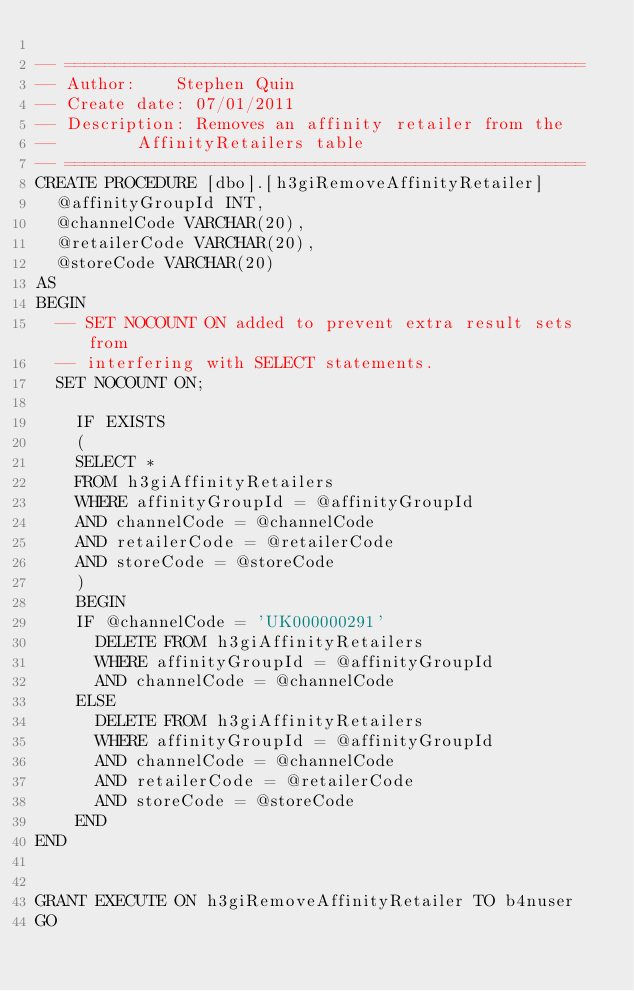Convert code to text. <code><loc_0><loc_0><loc_500><loc_500><_SQL_>
-- ====================================================
-- Author:		Stephen Quin
-- Create date: 07/01/2011
-- Description:	Removes an affinity retailer from the
--				AffinityRetailers table
-- ====================================================
CREATE PROCEDURE [dbo].[h3giRemoveAffinityRetailer] 
	@affinityGroupId INT,
	@channelCode VARCHAR(20),
	@retailerCode VARCHAR(20),
	@storeCode VARCHAR(20)
AS
BEGIN
	-- SET NOCOUNT ON added to prevent extra result sets from
	-- interfering with SELECT statements.
	SET NOCOUNT ON;

    IF EXISTS 
    (
		SELECT * 
		FROM h3giAffinityRetailers
		WHERE affinityGroupId = @affinityGroupId
		AND channelCode = @channelCode
		AND retailerCode = @retailerCode
		AND storeCode = @storeCode
    )
    BEGIN
		IF @channelCode = 'UK000000291'
			DELETE FROM h3giAffinityRetailers
			WHERE affinityGroupId = @affinityGroupId
			AND channelCode = @channelCode
		ELSE
			DELETE FROM h3giAffinityRetailers
			WHERE affinityGroupId = @affinityGroupId
			AND channelCode = @channelCode
			AND retailerCode = @retailerCode
			AND storeCode = @storeCode
    END
END


GRANT EXECUTE ON h3giRemoveAffinityRetailer TO b4nuser
GO
</code> 